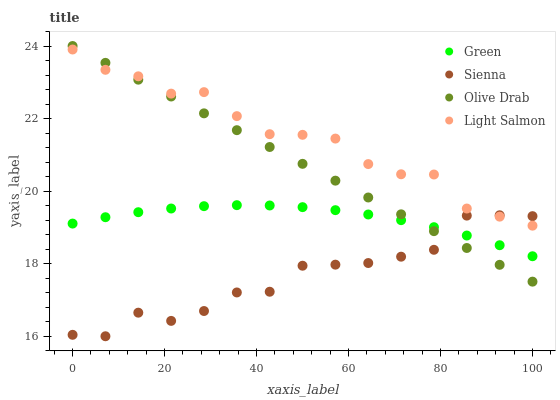Does Sienna have the minimum area under the curve?
Answer yes or no. Yes. Does Light Salmon have the maximum area under the curve?
Answer yes or no. Yes. Does Green have the minimum area under the curve?
Answer yes or no. No. Does Green have the maximum area under the curve?
Answer yes or no. No. Is Olive Drab the smoothest?
Answer yes or no. Yes. Is Sienna the roughest?
Answer yes or no. Yes. Is Light Salmon the smoothest?
Answer yes or no. No. Is Light Salmon the roughest?
Answer yes or no. No. Does Sienna have the lowest value?
Answer yes or no. Yes. Does Green have the lowest value?
Answer yes or no. No. Does Olive Drab have the highest value?
Answer yes or no. Yes. Does Light Salmon have the highest value?
Answer yes or no. No. Is Green less than Light Salmon?
Answer yes or no. Yes. Is Light Salmon greater than Green?
Answer yes or no. Yes. Does Olive Drab intersect Light Salmon?
Answer yes or no. Yes. Is Olive Drab less than Light Salmon?
Answer yes or no. No. Is Olive Drab greater than Light Salmon?
Answer yes or no. No. Does Green intersect Light Salmon?
Answer yes or no. No. 